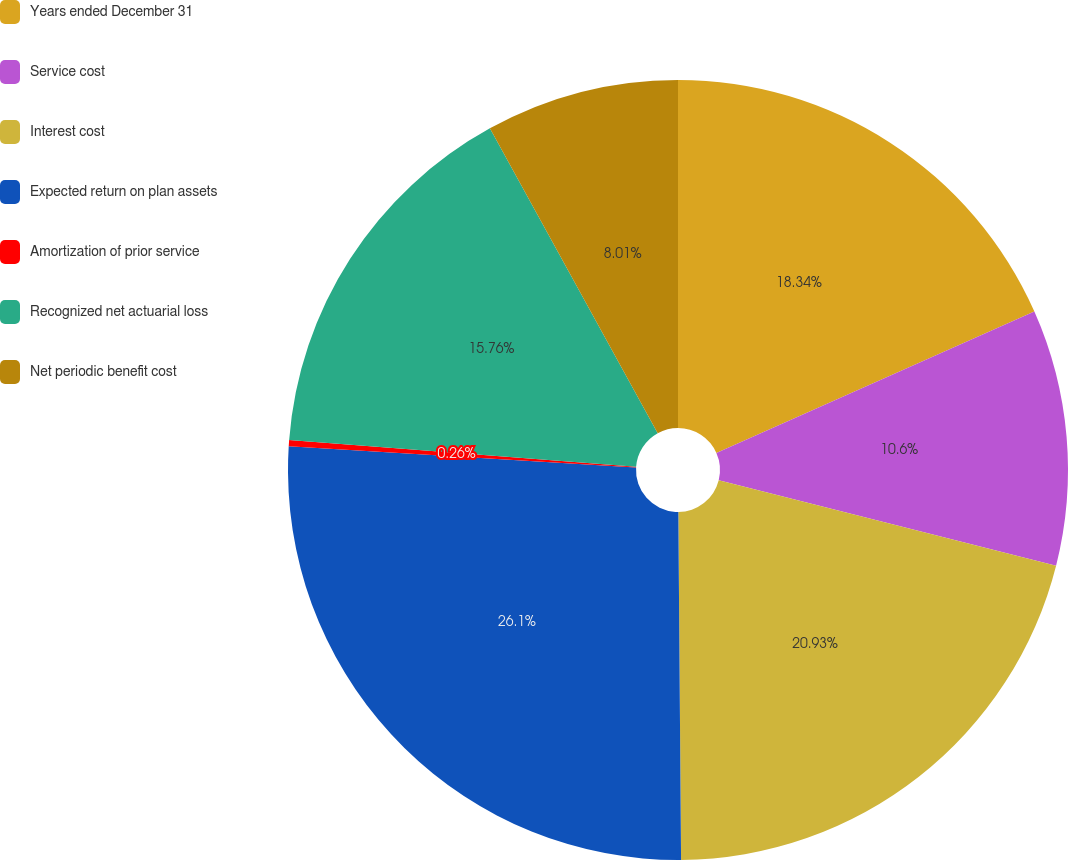<chart> <loc_0><loc_0><loc_500><loc_500><pie_chart><fcel>Years ended December 31<fcel>Service cost<fcel>Interest cost<fcel>Expected return on plan assets<fcel>Amortization of prior service<fcel>Recognized net actuarial loss<fcel>Net periodic benefit cost<nl><fcel>18.34%<fcel>10.6%<fcel>20.93%<fcel>26.09%<fcel>0.26%<fcel>15.76%<fcel>8.01%<nl></chart> 